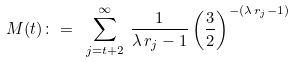<formula> <loc_0><loc_0><loc_500><loc_500>M ( t ) \colon = \ \sum _ { j = t + 2 } ^ { \infty } \, \frac { 1 } { \lambda \, r _ { j } - 1 } \left ( \frac { 3 } { 2 } \right ) ^ { - ( \lambda \, r _ { j } - 1 ) }</formula> 